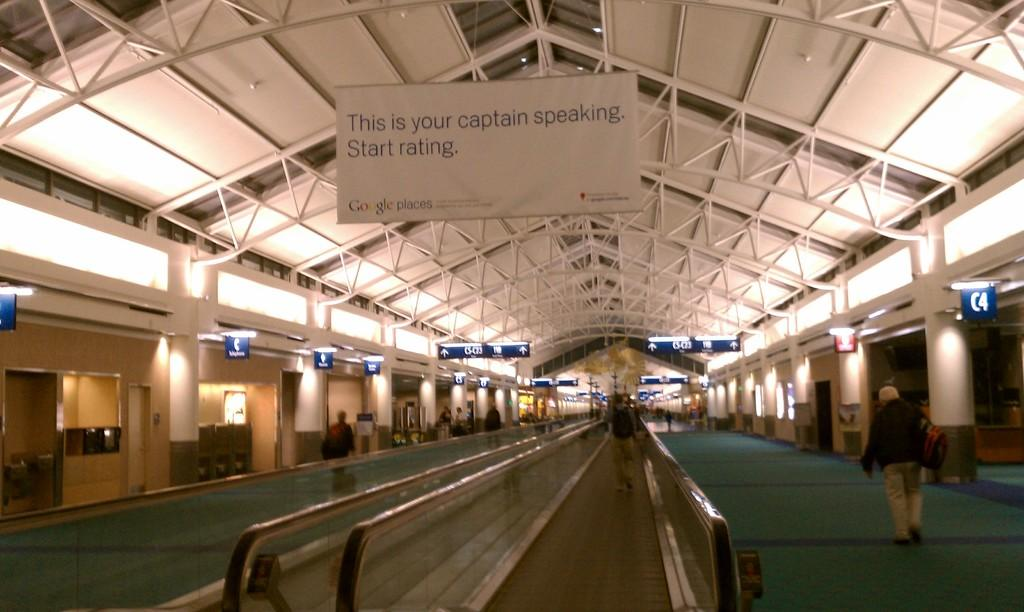Who is present in the image? There is a man in the image. What is the man doing in the image? The man is looking in the image. What object can be seen in the image besides the man? There is a board in the image. Where are the dolls located in the image? There are no dolls present in the image. What is the man dropping in the image? There is no indication in the image that the man is dropping anything. 